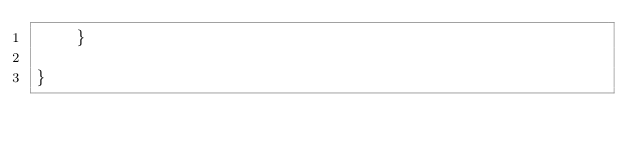<code> <loc_0><loc_0><loc_500><loc_500><_Java_>    }

}
</code> 